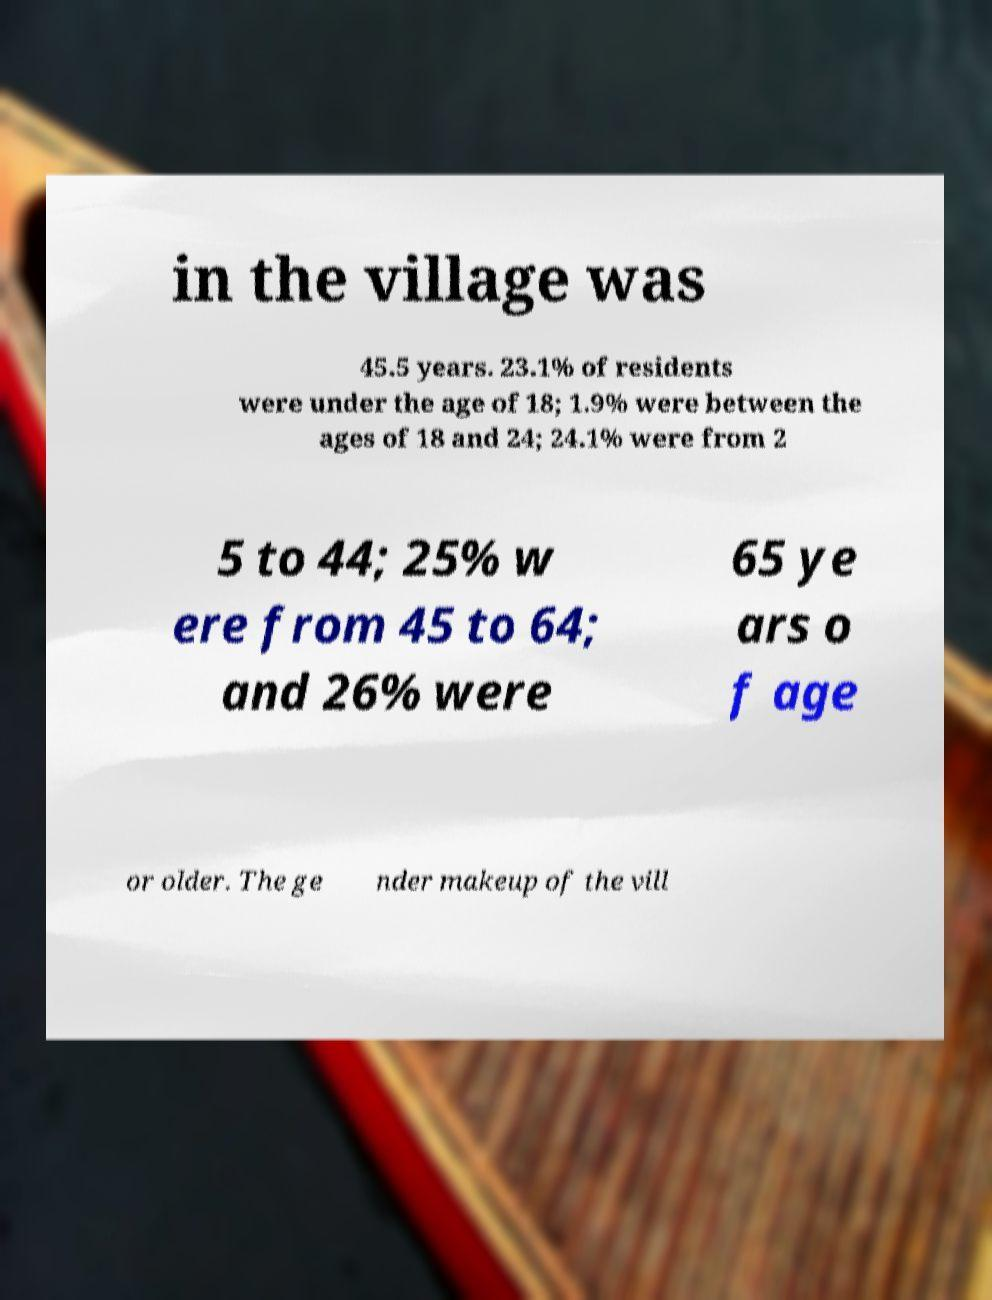Can you read and provide the text displayed in the image?This photo seems to have some interesting text. Can you extract and type it out for me? in the village was 45.5 years. 23.1% of residents were under the age of 18; 1.9% were between the ages of 18 and 24; 24.1% were from 2 5 to 44; 25% w ere from 45 to 64; and 26% were 65 ye ars o f age or older. The ge nder makeup of the vill 